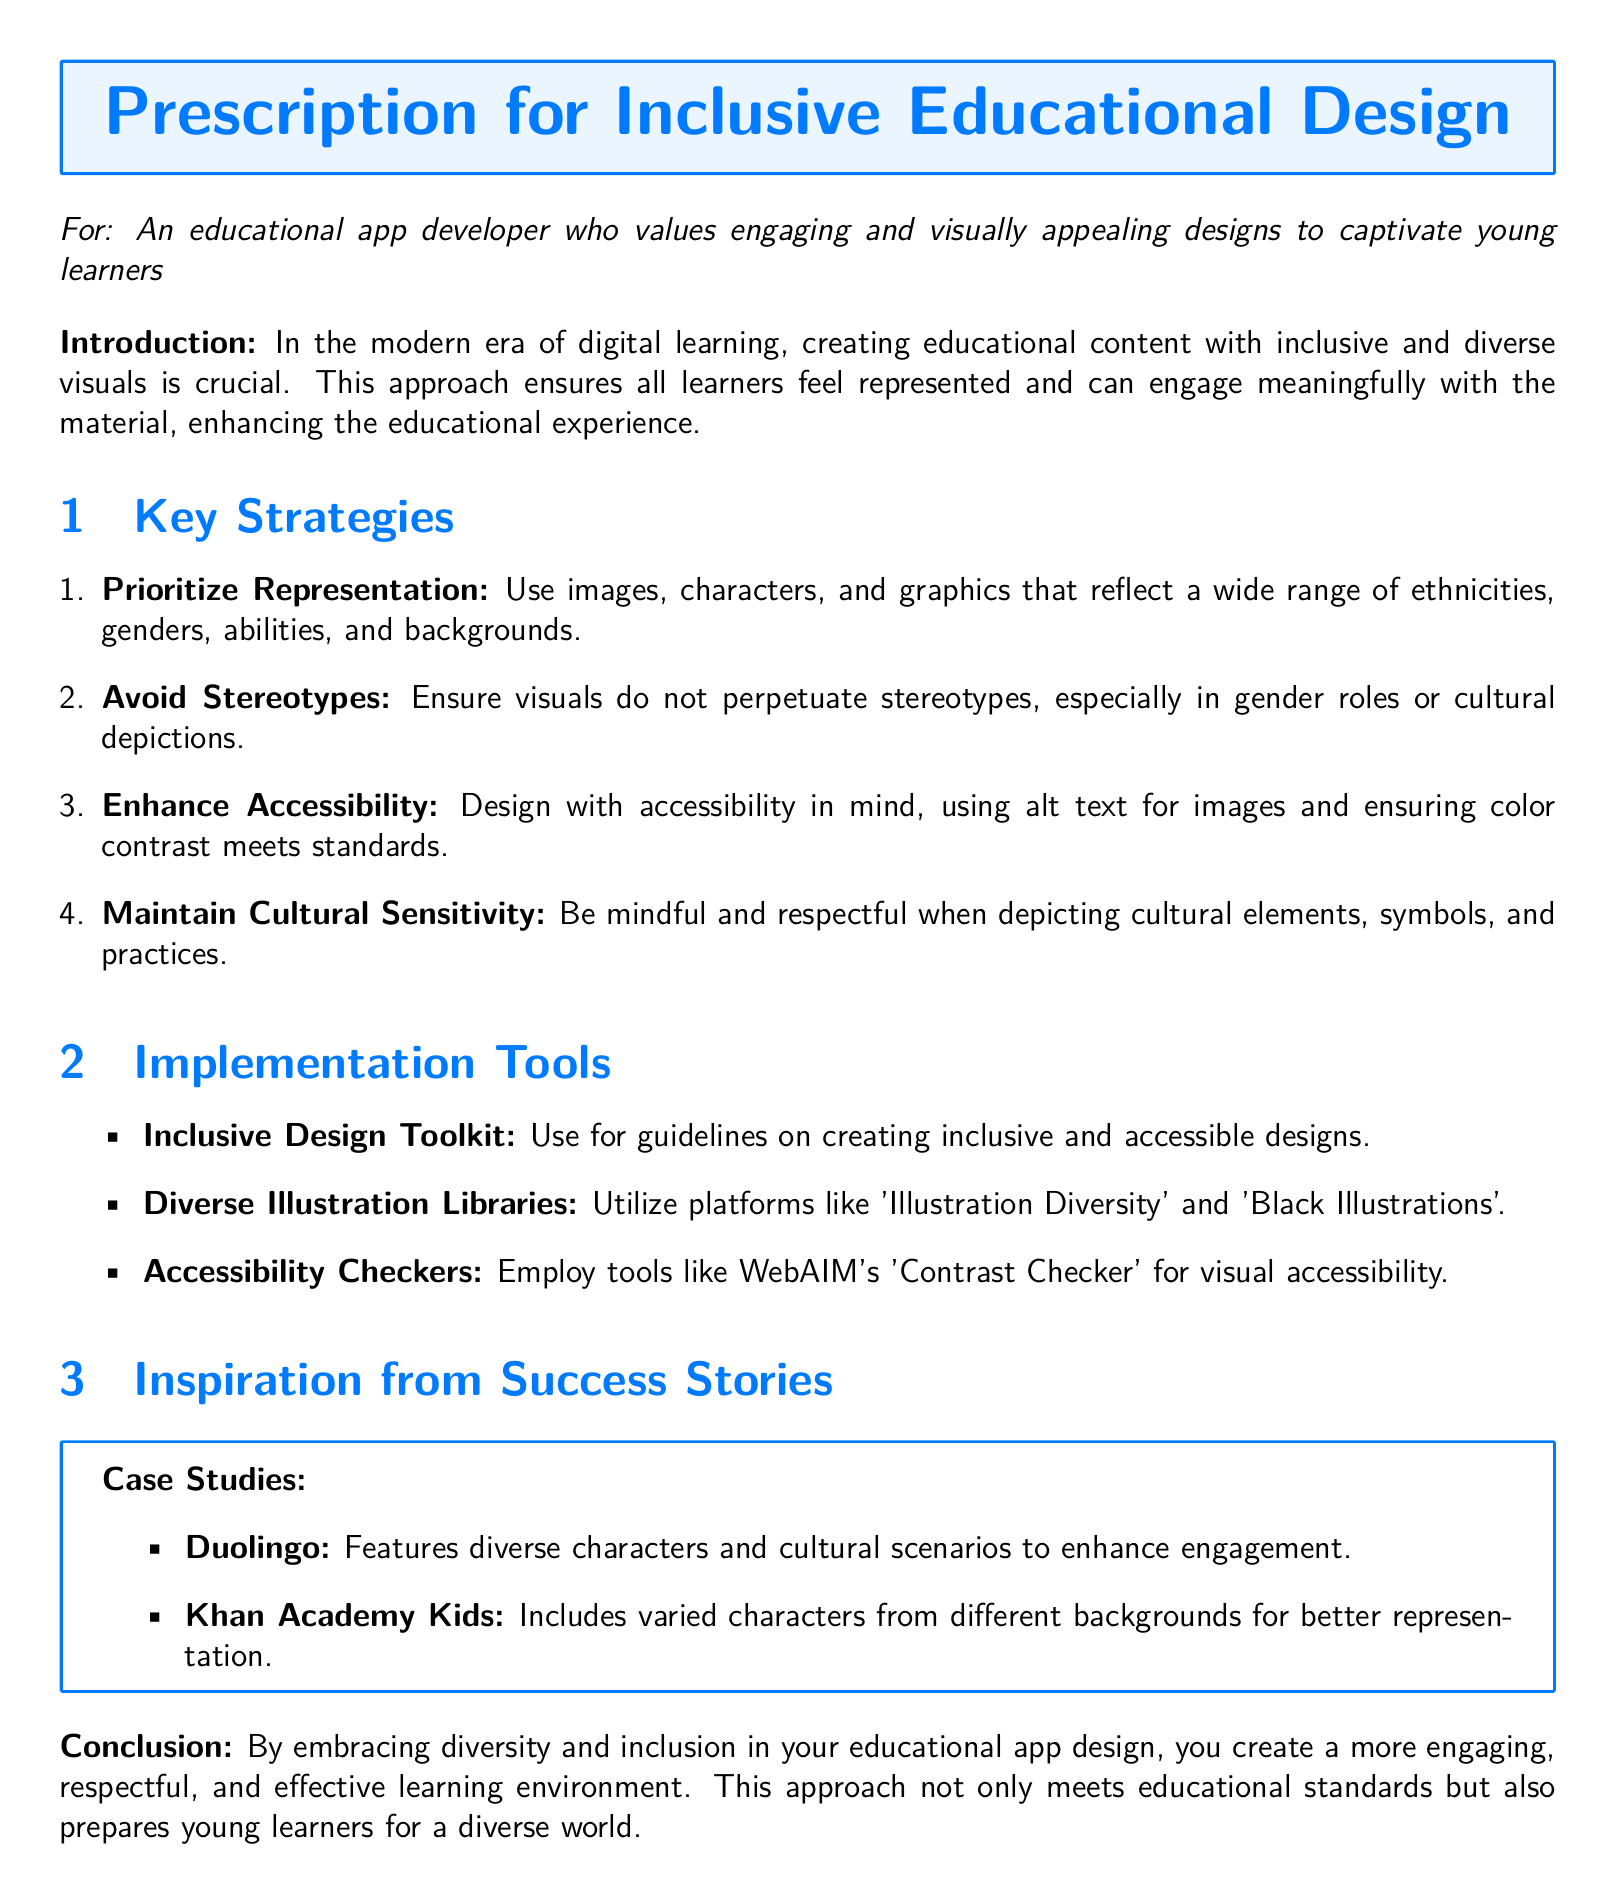What is the title of the document? The title of the document is presented at the beginning inside a colored box.
Answer: Prescription for Inclusive Educational Design Who is the intended audience for this document? The intended audience is mentioned specifically in the introduction section.
Answer: An educational app developer How many key strategies are listed in the document? The number of key strategies can be counted in the enumerated list under the "Key Strategies" section.
Answer: Four What is the purpose of the "Inclusive Design Toolkit"? The purpose of the toolkit is inferred from the context in which it is introduced.
Answer: Guidelines on creating inclusive and accessible designs Which educational app is mentioned as a case study for featuring diverse characters? The case study is referenced in the "Inspiration from Success Stories" section.
Answer: Duolingo What is emphasized regarding cultural elements? The document specifies a guideline about cultural elements in the "Key Strategies" section.
Answer: Cultural sensitivity Name one tool suggested for checking visual accessibility. The tools are mentioned in the "Implementation Tools" section, and one can be selected from it.
Answer: WebAIM's Contrast Checker What is the ultimate goal of embracing diversity in educational app design? The ultimate goal is articulated in the conclusion of the document.
Answer: Create a more engaging, respectful, and effective learning environment 